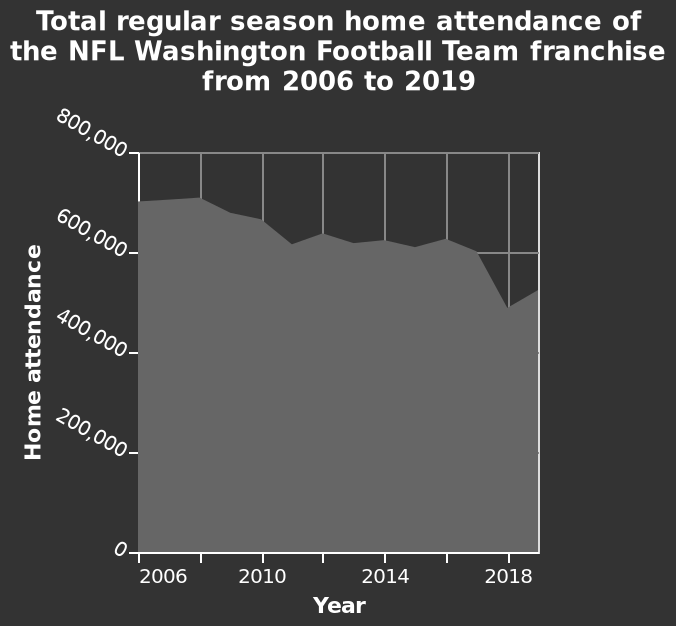<image>
What is the name of the graph?  The graph is named Total regular season home attendance. 